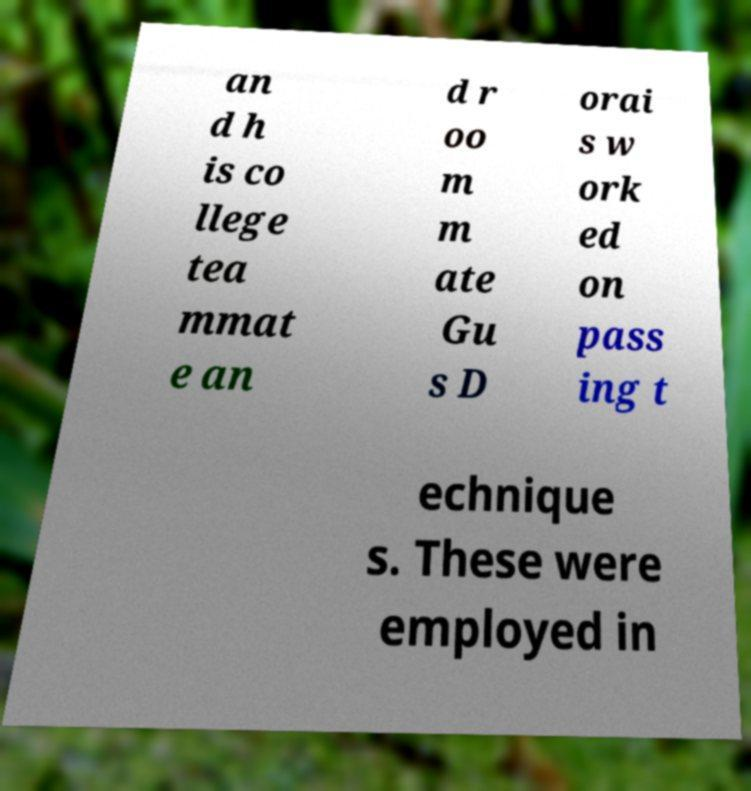For documentation purposes, I need the text within this image transcribed. Could you provide that? an d h is co llege tea mmat e an d r oo m m ate Gu s D orai s w ork ed on pass ing t echnique s. These were employed in 